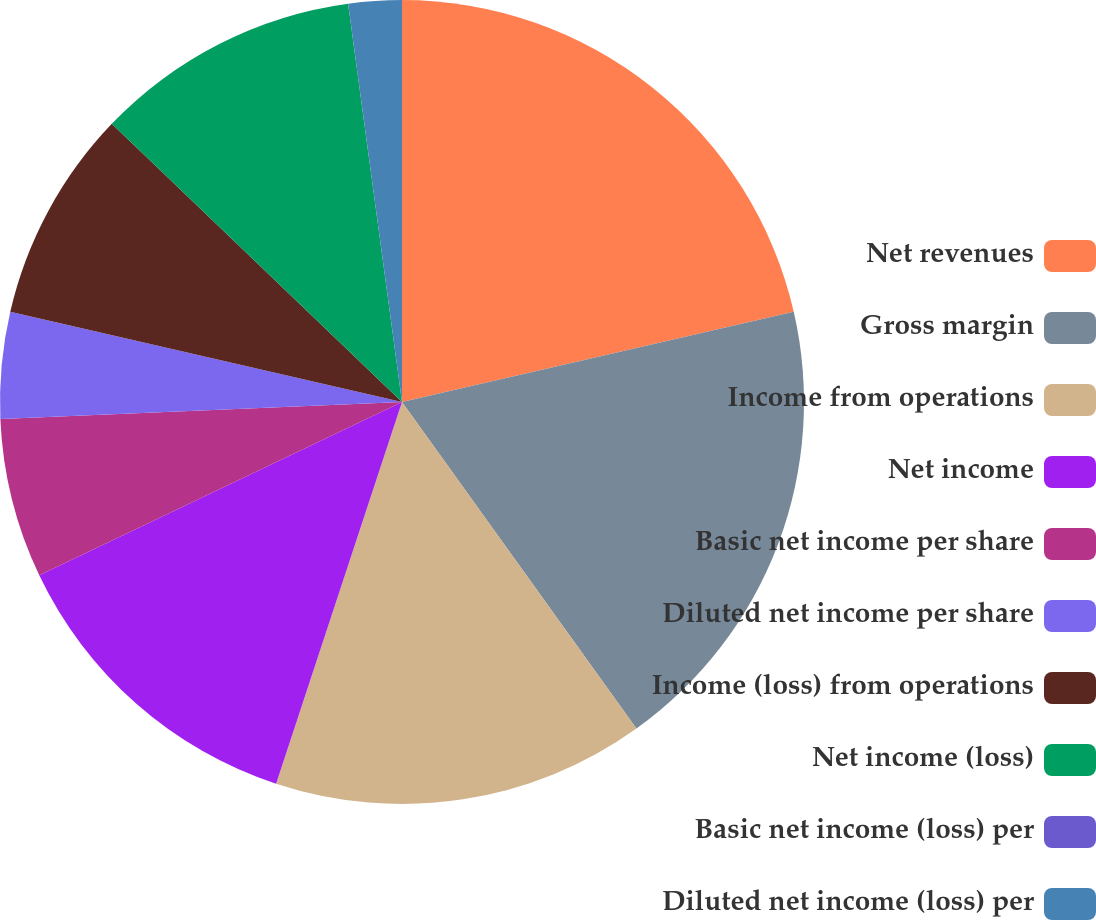<chart> <loc_0><loc_0><loc_500><loc_500><pie_chart><fcel>Net revenues<fcel>Gross margin<fcel>Income from operations<fcel>Net income<fcel>Basic net income per share<fcel>Diluted net income per share<fcel>Income (loss) from operations<fcel>Net income (loss)<fcel>Basic net income (loss) per<fcel>Diluted net income (loss) per<nl><fcel>21.4%<fcel>18.7%<fcel>14.98%<fcel>12.84%<fcel>6.42%<fcel>4.28%<fcel>8.56%<fcel>10.7%<fcel>0.0%<fcel>2.14%<nl></chart> 